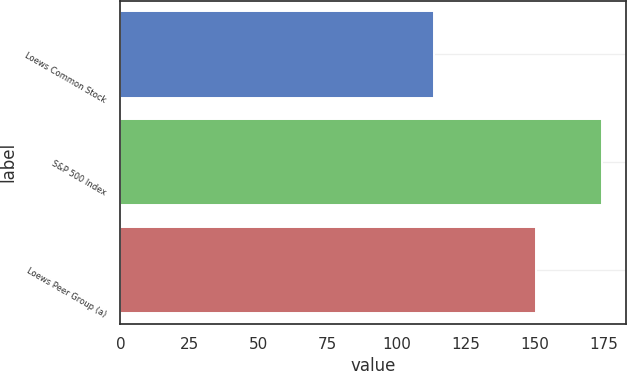<chart> <loc_0><loc_0><loc_500><loc_500><bar_chart><fcel>Loews Common Stock<fcel>S&P 500 Index<fcel>Loews Peer Group (a)<nl><fcel>113.59<fcel>174.6<fcel>150.44<nl></chart> 